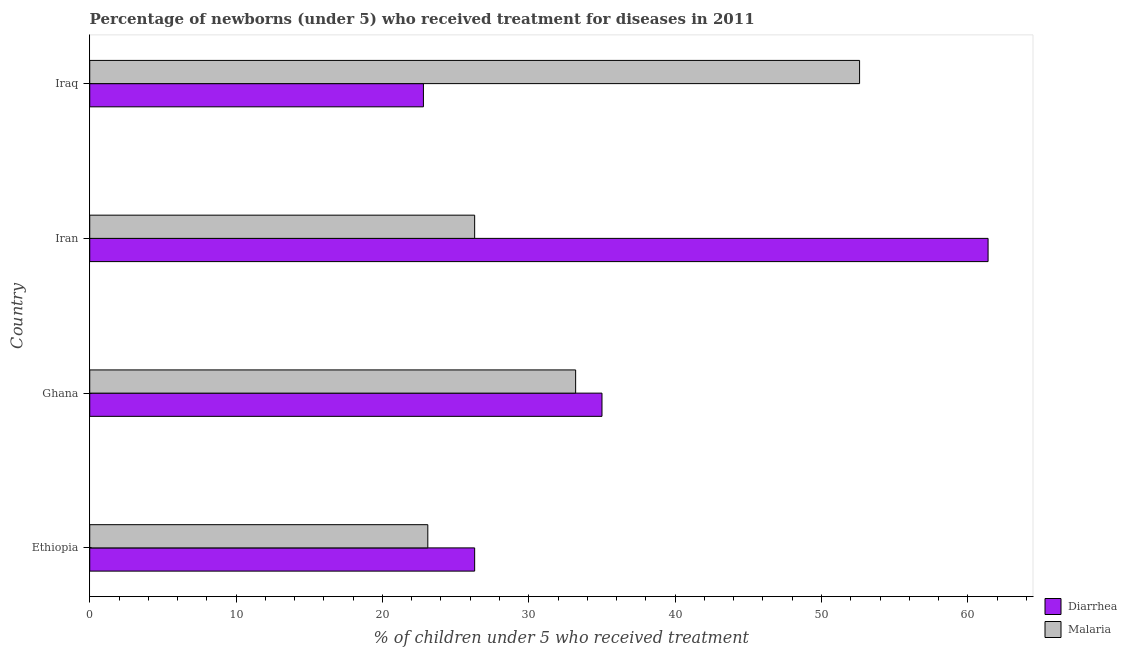How many groups of bars are there?
Your answer should be very brief. 4. Are the number of bars per tick equal to the number of legend labels?
Offer a terse response. Yes. How many bars are there on the 4th tick from the bottom?
Make the answer very short. 2. What is the label of the 1st group of bars from the top?
Give a very brief answer. Iraq. In how many cases, is the number of bars for a given country not equal to the number of legend labels?
Offer a very short reply. 0. What is the percentage of children who received treatment for malaria in Ghana?
Your response must be concise. 33.2. Across all countries, what is the maximum percentage of children who received treatment for diarrhoea?
Offer a very short reply. 61.38. Across all countries, what is the minimum percentage of children who received treatment for diarrhoea?
Keep it short and to the point. 22.8. In which country was the percentage of children who received treatment for malaria maximum?
Your response must be concise. Iraq. In which country was the percentage of children who received treatment for malaria minimum?
Your answer should be compact. Ethiopia. What is the total percentage of children who received treatment for diarrhoea in the graph?
Your answer should be very brief. 145.48. What is the difference between the percentage of children who received treatment for diarrhoea in Iran and that in Iraq?
Provide a short and direct response. 38.58. What is the average percentage of children who received treatment for malaria per country?
Offer a very short reply. 33.8. What is the difference between the percentage of children who received treatment for diarrhoea and percentage of children who received treatment for malaria in Iraq?
Offer a terse response. -29.8. What is the ratio of the percentage of children who received treatment for diarrhoea in Ethiopia to that in Iraq?
Offer a very short reply. 1.15. What is the difference between the highest and the second highest percentage of children who received treatment for malaria?
Offer a terse response. 19.4. What is the difference between the highest and the lowest percentage of children who received treatment for diarrhoea?
Your answer should be very brief. 38.58. Is the sum of the percentage of children who received treatment for malaria in Ethiopia and Iran greater than the maximum percentage of children who received treatment for diarrhoea across all countries?
Give a very brief answer. No. What does the 1st bar from the top in Iran represents?
Provide a short and direct response. Malaria. What does the 1st bar from the bottom in Iran represents?
Make the answer very short. Diarrhea. Are all the bars in the graph horizontal?
Your answer should be compact. Yes. How many countries are there in the graph?
Provide a short and direct response. 4. What is the difference between two consecutive major ticks on the X-axis?
Keep it short and to the point. 10. Does the graph contain any zero values?
Offer a terse response. No. How many legend labels are there?
Your response must be concise. 2. How are the legend labels stacked?
Make the answer very short. Vertical. What is the title of the graph?
Provide a short and direct response. Percentage of newborns (under 5) who received treatment for diseases in 2011. Does "Death rate" appear as one of the legend labels in the graph?
Keep it short and to the point. No. What is the label or title of the X-axis?
Your answer should be compact. % of children under 5 who received treatment. What is the label or title of the Y-axis?
Provide a short and direct response. Country. What is the % of children under 5 who received treatment in Diarrhea in Ethiopia?
Make the answer very short. 26.3. What is the % of children under 5 who received treatment in Malaria in Ethiopia?
Ensure brevity in your answer.  23.1. What is the % of children under 5 who received treatment of Malaria in Ghana?
Your response must be concise. 33.2. What is the % of children under 5 who received treatment in Diarrhea in Iran?
Your answer should be very brief. 61.38. What is the % of children under 5 who received treatment in Malaria in Iran?
Offer a terse response. 26.3. What is the % of children under 5 who received treatment of Diarrhea in Iraq?
Offer a very short reply. 22.8. What is the % of children under 5 who received treatment of Malaria in Iraq?
Keep it short and to the point. 52.6. Across all countries, what is the maximum % of children under 5 who received treatment in Diarrhea?
Ensure brevity in your answer.  61.38. Across all countries, what is the maximum % of children under 5 who received treatment in Malaria?
Your response must be concise. 52.6. Across all countries, what is the minimum % of children under 5 who received treatment of Diarrhea?
Offer a very short reply. 22.8. Across all countries, what is the minimum % of children under 5 who received treatment of Malaria?
Offer a very short reply. 23.1. What is the total % of children under 5 who received treatment of Diarrhea in the graph?
Ensure brevity in your answer.  145.48. What is the total % of children under 5 who received treatment in Malaria in the graph?
Give a very brief answer. 135.2. What is the difference between the % of children under 5 who received treatment of Diarrhea in Ethiopia and that in Ghana?
Your response must be concise. -8.7. What is the difference between the % of children under 5 who received treatment of Malaria in Ethiopia and that in Ghana?
Provide a short and direct response. -10.1. What is the difference between the % of children under 5 who received treatment in Diarrhea in Ethiopia and that in Iran?
Your answer should be very brief. -35.08. What is the difference between the % of children under 5 who received treatment in Malaria in Ethiopia and that in Iraq?
Keep it short and to the point. -29.5. What is the difference between the % of children under 5 who received treatment in Diarrhea in Ghana and that in Iran?
Make the answer very short. -26.38. What is the difference between the % of children under 5 who received treatment in Diarrhea in Ghana and that in Iraq?
Offer a terse response. 12.2. What is the difference between the % of children under 5 who received treatment in Malaria in Ghana and that in Iraq?
Give a very brief answer. -19.4. What is the difference between the % of children under 5 who received treatment of Diarrhea in Iran and that in Iraq?
Make the answer very short. 38.58. What is the difference between the % of children under 5 who received treatment of Malaria in Iran and that in Iraq?
Your response must be concise. -26.3. What is the difference between the % of children under 5 who received treatment in Diarrhea in Ethiopia and the % of children under 5 who received treatment in Malaria in Ghana?
Give a very brief answer. -6.9. What is the difference between the % of children under 5 who received treatment of Diarrhea in Ethiopia and the % of children under 5 who received treatment of Malaria in Iran?
Offer a very short reply. 0. What is the difference between the % of children under 5 who received treatment in Diarrhea in Ethiopia and the % of children under 5 who received treatment in Malaria in Iraq?
Your answer should be compact. -26.3. What is the difference between the % of children under 5 who received treatment in Diarrhea in Ghana and the % of children under 5 who received treatment in Malaria in Iraq?
Provide a short and direct response. -17.6. What is the difference between the % of children under 5 who received treatment of Diarrhea in Iran and the % of children under 5 who received treatment of Malaria in Iraq?
Offer a terse response. 8.78. What is the average % of children under 5 who received treatment in Diarrhea per country?
Your response must be concise. 36.37. What is the average % of children under 5 who received treatment in Malaria per country?
Keep it short and to the point. 33.8. What is the difference between the % of children under 5 who received treatment in Diarrhea and % of children under 5 who received treatment in Malaria in Ethiopia?
Your answer should be compact. 3.2. What is the difference between the % of children under 5 who received treatment in Diarrhea and % of children under 5 who received treatment in Malaria in Ghana?
Give a very brief answer. 1.8. What is the difference between the % of children under 5 who received treatment in Diarrhea and % of children under 5 who received treatment in Malaria in Iran?
Provide a succinct answer. 35.08. What is the difference between the % of children under 5 who received treatment in Diarrhea and % of children under 5 who received treatment in Malaria in Iraq?
Ensure brevity in your answer.  -29.8. What is the ratio of the % of children under 5 who received treatment of Diarrhea in Ethiopia to that in Ghana?
Offer a very short reply. 0.75. What is the ratio of the % of children under 5 who received treatment of Malaria in Ethiopia to that in Ghana?
Your answer should be very brief. 0.7. What is the ratio of the % of children under 5 who received treatment of Diarrhea in Ethiopia to that in Iran?
Give a very brief answer. 0.43. What is the ratio of the % of children under 5 who received treatment in Malaria in Ethiopia to that in Iran?
Make the answer very short. 0.88. What is the ratio of the % of children under 5 who received treatment in Diarrhea in Ethiopia to that in Iraq?
Provide a succinct answer. 1.15. What is the ratio of the % of children under 5 who received treatment of Malaria in Ethiopia to that in Iraq?
Your answer should be very brief. 0.44. What is the ratio of the % of children under 5 who received treatment in Diarrhea in Ghana to that in Iran?
Provide a short and direct response. 0.57. What is the ratio of the % of children under 5 who received treatment of Malaria in Ghana to that in Iran?
Offer a terse response. 1.26. What is the ratio of the % of children under 5 who received treatment in Diarrhea in Ghana to that in Iraq?
Provide a succinct answer. 1.54. What is the ratio of the % of children under 5 who received treatment of Malaria in Ghana to that in Iraq?
Keep it short and to the point. 0.63. What is the ratio of the % of children under 5 who received treatment of Diarrhea in Iran to that in Iraq?
Your answer should be very brief. 2.69. What is the ratio of the % of children under 5 who received treatment of Malaria in Iran to that in Iraq?
Give a very brief answer. 0.5. What is the difference between the highest and the second highest % of children under 5 who received treatment of Diarrhea?
Your answer should be very brief. 26.38. What is the difference between the highest and the second highest % of children under 5 who received treatment in Malaria?
Keep it short and to the point. 19.4. What is the difference between the highest and the lowest % of children under 5 who received treatment in Diarrhea?
Provide a succinct answer. 38.58. What is the difference between the highest and the lowest % of children under 5 who received treatment of Malaria?
Ensure brevity in your answer.  29.5. 